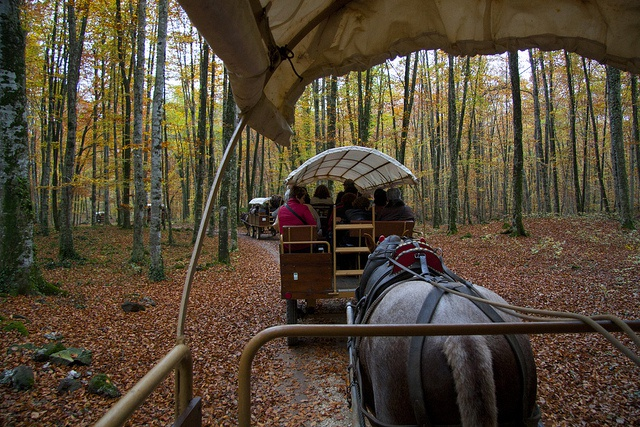Describe the objects in this image and their specific colors. I can see horse in black, gray, and darkgray tones, people in black, maroon, and purple tones, people in black and gray tones, people in black and gray tones, and people in black, maroon, and navy tones in this image. 